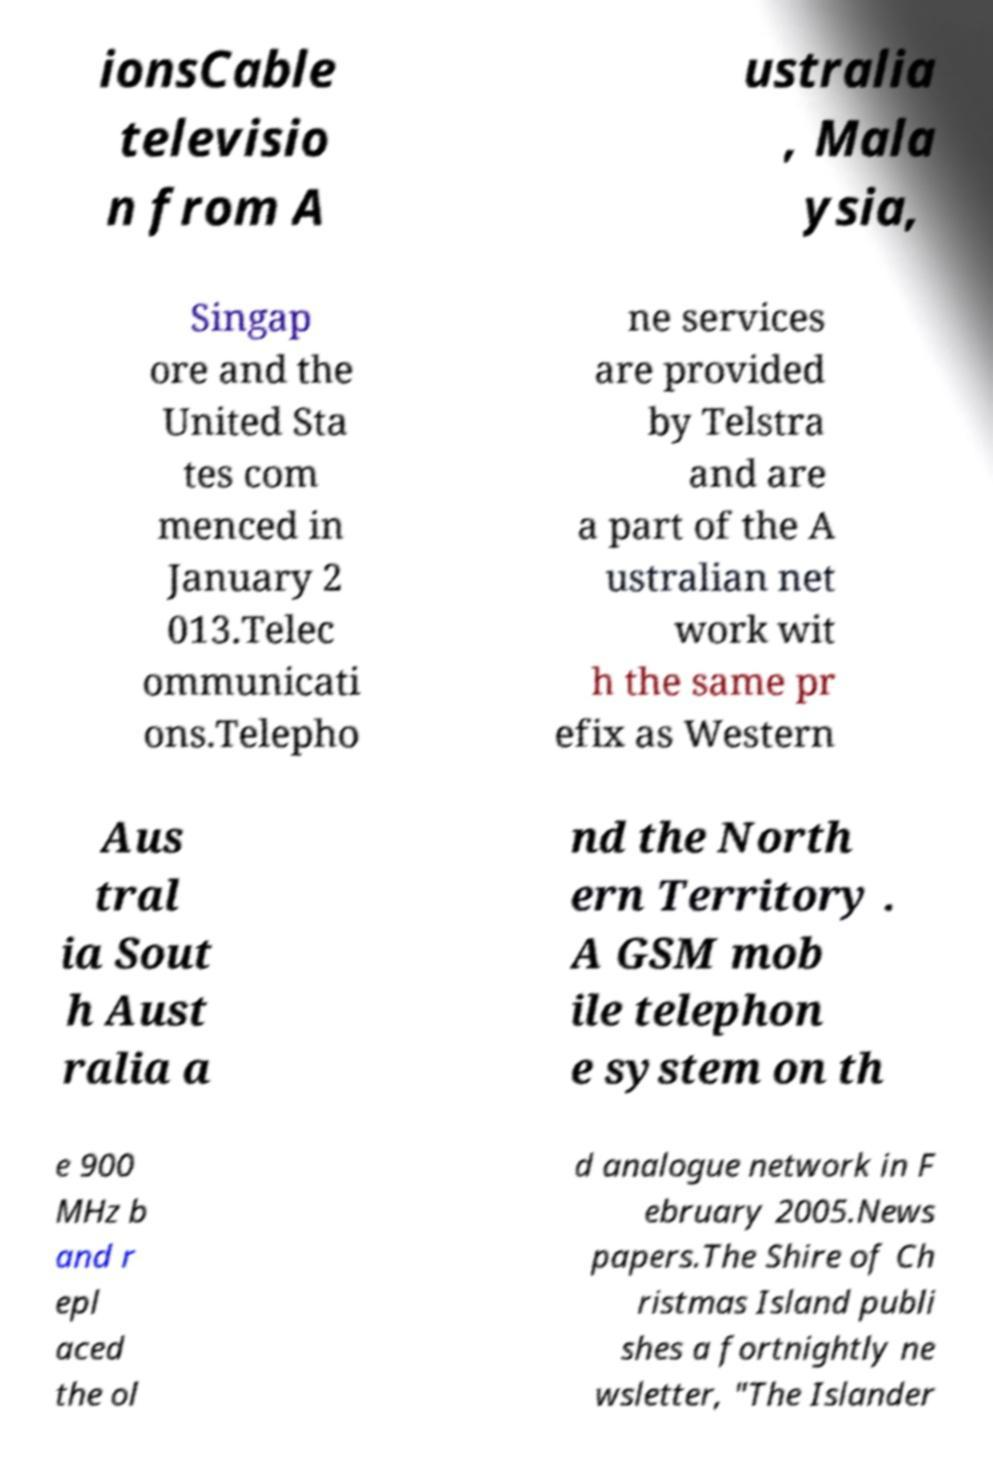What messages or text are displayed in this image? I need them in a readable, typed format. ionsCable televisio n from A ustralia , Mala ysia, Singap ore and the United Sta tes com menced in January 2 013.Telec ommunicati ons.Telepho ne services are provided by Telstra and are a part of the A ustralian net work wit h the same pr efix as Western Aus tral ia Sout h Aust ralia a nd the North ern Territory . A GSM mob ile telephon e system on th e 900 MHz b and r epl aced the ol d analogue network in F ebruary 2005.News papers.The Shire of Ch ristmas Island publi shes a fortnightly ne wsletter, "The Islander 